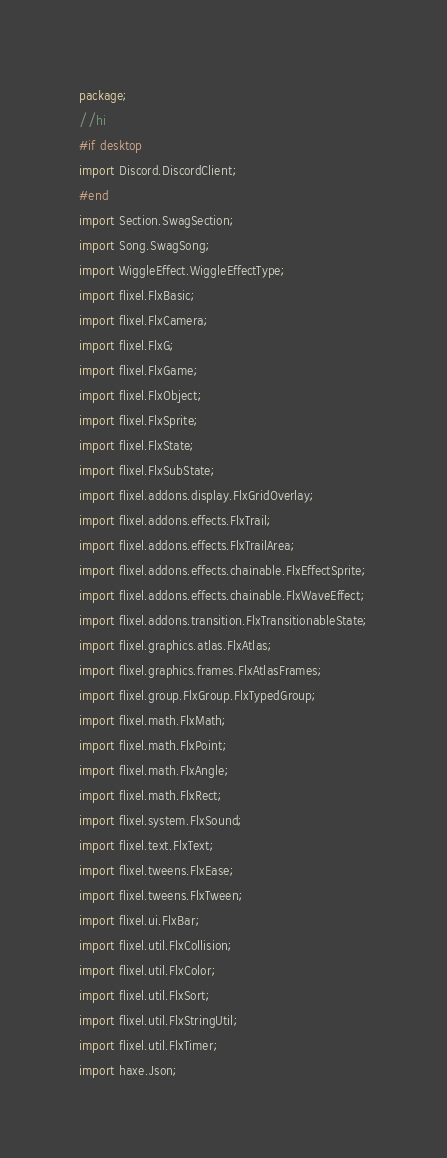Convert code to text. <code><loc_0><loc_0><loc_500><loc_500><_Haxe_>package;
//hi
#if desktop
import Discord.DiscordClient;
#end
import Section.SwagSection;
import Song.SwagSong;
import WiggleEffect.WiggleEffectType;
import flixel.FlxBasic;
import flixel.FlxCamera;
import flixel.FlxG;
import flixel.FlxGame;
import flixel.FlxObject;
import flixel.FlxSprite;
import flixel.FlxState;
import flixel.FlxSubState;
import flixel.addons.display.FlxGridOverlay;
import flixel.addons.effects.FlxTrail;
import flixel.addons.effects.FlxTrailArea;
import flixel.addons.effects.chainable.FlxEffectSprite;
import flixel.addons.effects.chainable.FlxWaveEffect;
import flixel.addons.transition.FlxTransitionableState;
import flixel.graphics.atlas.FlxAtlas;
import flixel.graphics.frames.FlxAtlasFrames;
import flixel.group.FlxGroup.FlxTypedGroup;
import flixel.math.FlxMath;
import flixel.math.FlxPoint;
import flixel.math.FlxAngle;
import flixel.math.FlxRect;
import flixel.system.FlxSound;
import flixel.text.FlxText;
import flixel.tweens.FlxEase;
import flixel.tweens.FlxTween;
import flixel.ui.FlxBar;
import flixel.util.FlxCollision;
import flixel.util.FlxColor;
import flixel.util.FlxSort;
import flixel.util.FlxStringUtil;
import flixel.util.FlxTimer;
import haxe.Json;</code> 